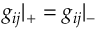Convert formula to latex. <formula><loc_0><loc_0><loc_500><loc_500>g _ { i j } { | } _ { + } = g _ { i j } { | } _ { - }</formula> 